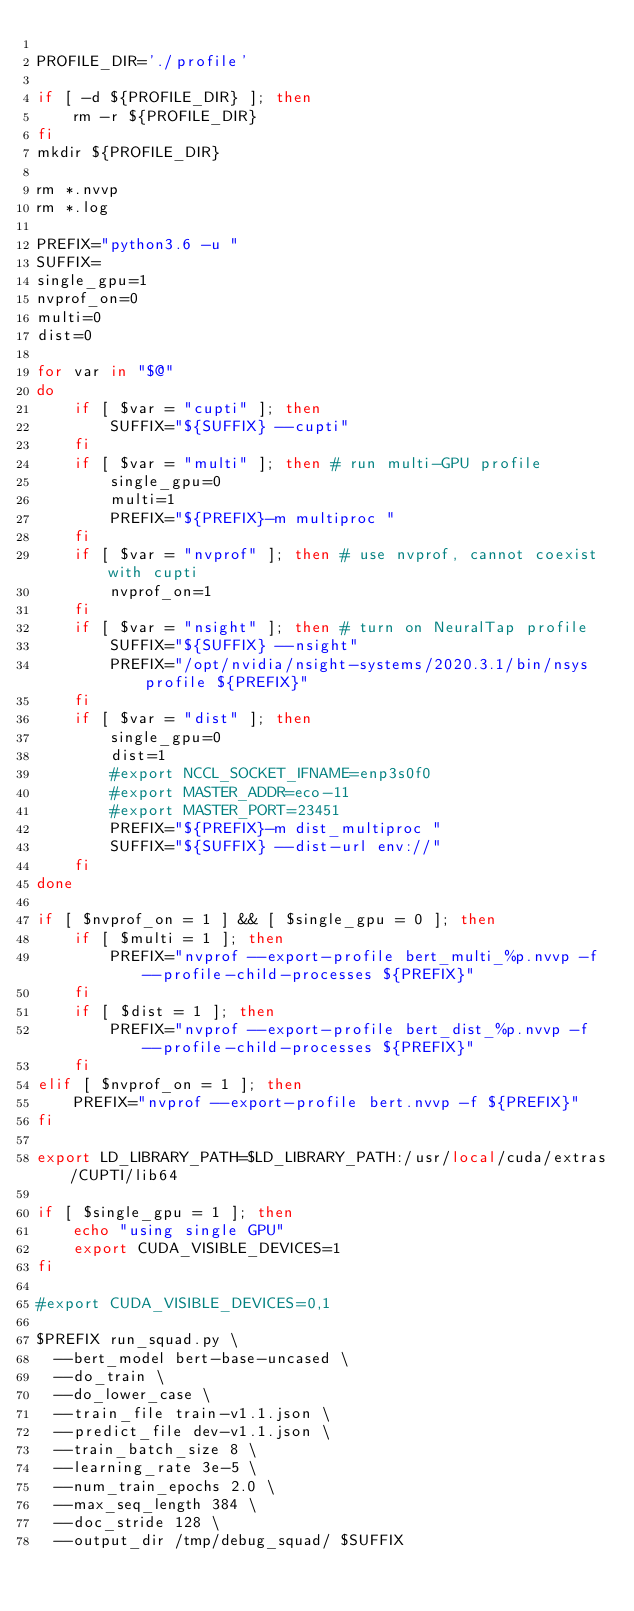Convert code to text. <code><loc_0><loc_0><loc_500><loc_500><_Bash_>
PROFILE_DIR='./profile'

if [ -d ${PROFILE_DIR} ]; then
    rm -r ${PROFILE_DIR}
fi
mkdir ${PROFILE_DIR}

rm *.nvvp
rm *.log

PREFIX="python3.6 -u "
SUFFIX=
single_gpu=1
nvprof_on=0
multi=0
dist=0

for var in "$@"
do
    if [ $var = "cupti" ]; then
        SUFFIX="${SUFFIX} --cupti"
    fi
    if [ $var = "multi" ]; then # run multi-GPU profile
        single_gpu=0
        multi=1
        PREFIX="${PREFIX}-m multiproc "
    fi
    if [ $var = "nvprof" ]; then # use nvprof, cannot coexist with cupti
        nvprof_on=1
    fi
    if [ $var = "nsight" ]; then # turn on NeuralTap profile
        SUFFIX="${SUFFIX} --nsight"
        PREFIX="/opt/nvidia/nsight-systems/2020.3.1/bin/nsys profile ${PREFIX}"
    fi
    if [ $var = "dist" ]; then
        single_gpu=0
        dist=1
        #export NCCL_SOCKET_IFNAME=enp3s0f0
        #export MASTER_ADDR=eco-11
        #export MASTER_PORT=23451
        PREFIX="${PREFIX}-m dist_multiproc "
        SUFFIX="${SUFFIX} --dist-url env://"
    fi
done

if [ $nvprof_on = 1 ] && [ $single_gpu = 0 ]; then
    if [ $multi = 1 ]; then
        PREFIX="nvprof --export-profile bert_multi_%p.nvvp -f --profile-child-processes ${PREFIX}"
    fi
    if [ $dist = 1 ]; then
        PREFIX="nvprof --export-profile bert_dist_%p.nvvp -f --profile-child-processes ${PREFIX}"
    fi
elif [ $nvprof_on = 1 ]; then
    PREFIX="nvprof --export-profile bert.nvvp -f ${PREFIX}"
fi

export LD_LIBRARY_PATH=$LD_LIBRARY_PATH:/usr/local/cuda/extras/CUPTI/lib64

if [ $single_gpu = 1 ]; then
    echo "using single GPU"
    export CUDA_VISIBLE_DEVICES=1
fi

#export CUDA_VISIBLE_DEVICES=0,1

$PREFIX run_squad.py \
  --bert_model bert-base-uncased \
  --do_train \
  --do_lower_case \
  --train_file train-v1.1.json \
  --predict_file dev-v1.1.json \
  --train_batch_size 8 \
  --learning_rate 3e-5 \
  --num_train_epochs 2.0 \
  --max_seq_length 384 \
  --doc_stride 128 \
  --output_dir /tmp/debug_squad/ $SUFFIX
</code> 